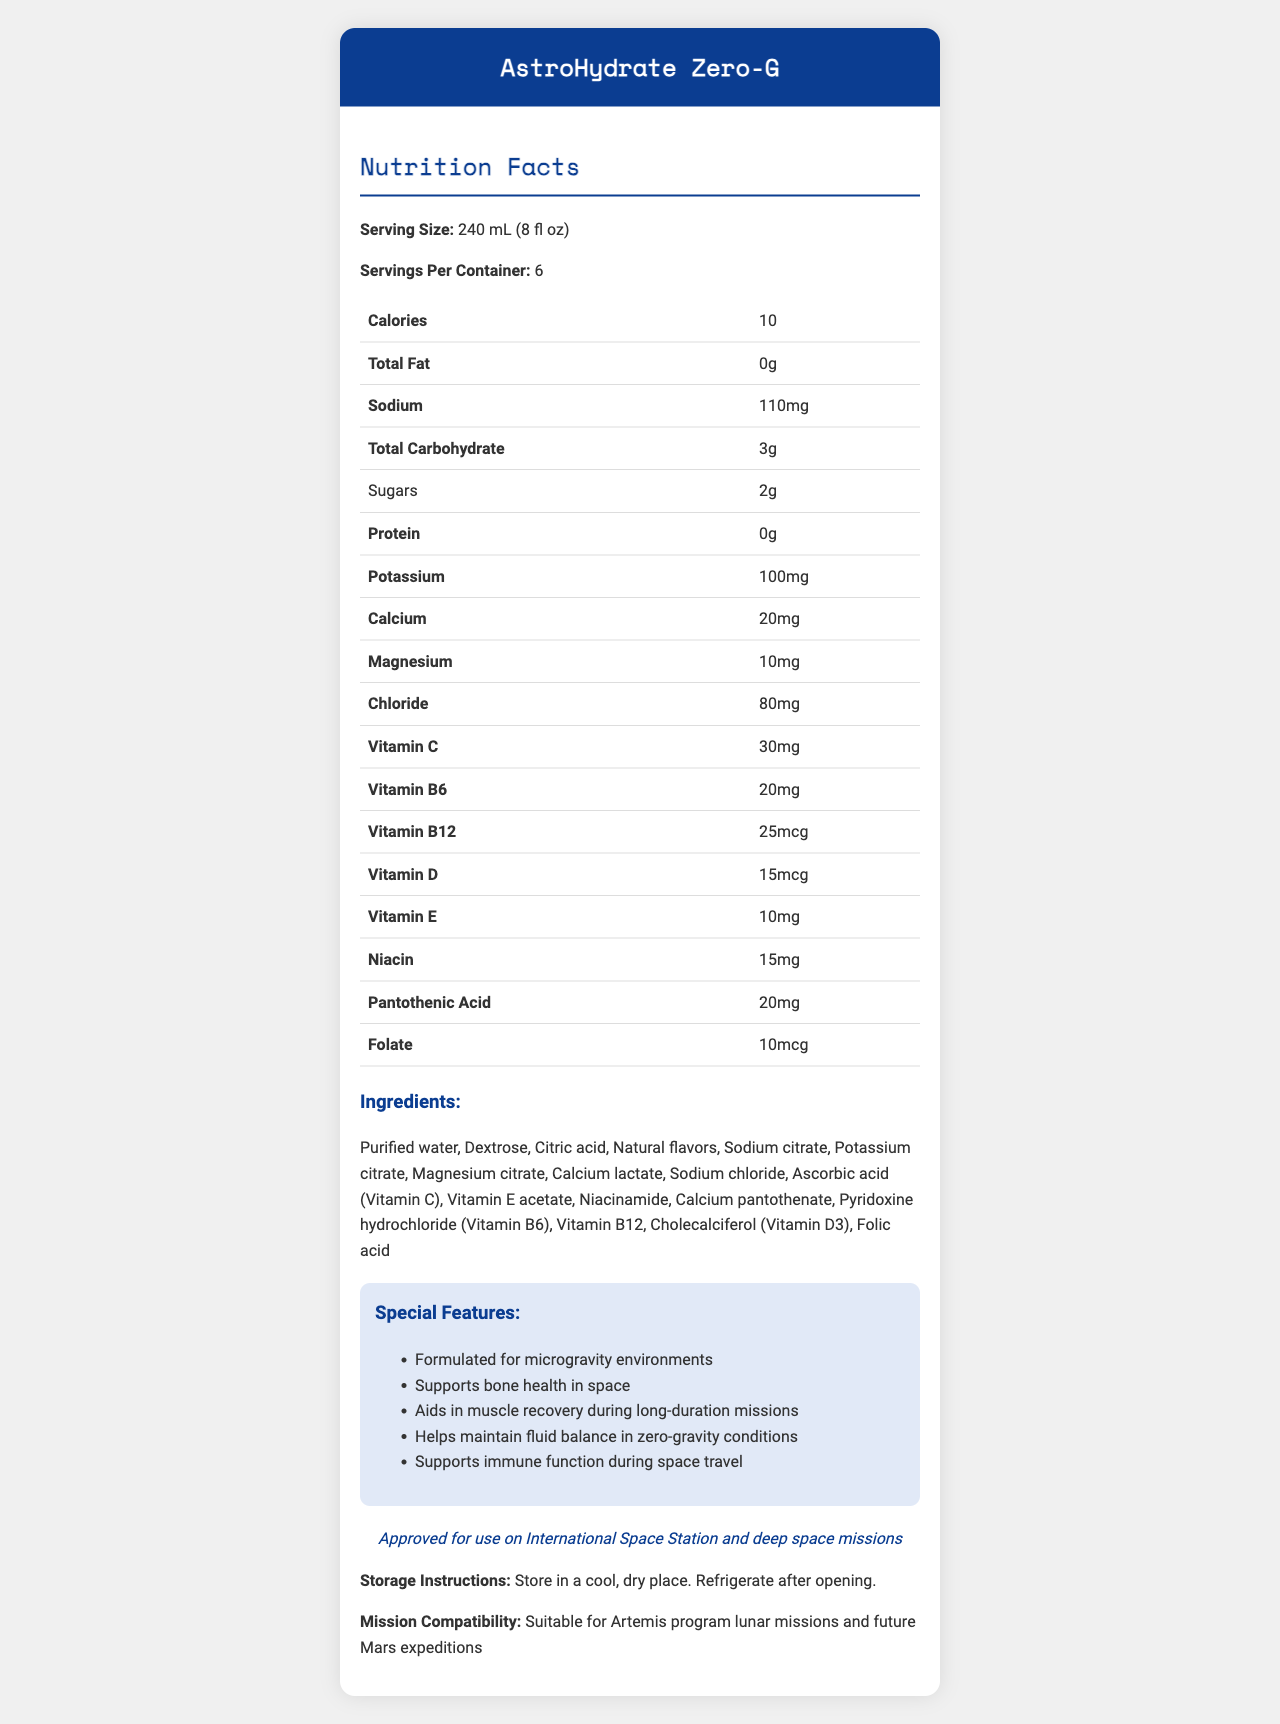what is the serving size for AstroHydrate Zero-G? The serving size is clearly stated at the beginning of the nutrition facts section.
Answer: 240 mL (8 fl oz) how many calories are there per serving of AstroHydrate Zero-G? The number of calories per serving is listed in the nutrition facts table.
Answer: 10 what vitamins are included in AstroHydrate Zero-G? The nutrition facts table lists all the vitamins included in the drink.
Answer: Vitamins C, B6, B12, D, E, Niacin, Pantothenic Acid, Folate how much sodium is in one serving of AstroHydrate Zero-G? The sodium content is listed as 110 mg in the nutrition facts table.
Answer: 110 mg which ingredient is listed first in the ingredients list? The ingredients are listed in order of quantity, with purified water being the first ingredient.
Answer: Purified water which of the following features is NOT mentioned as a special feature of AstroHydrate Zero-G? A. Supports bone health in space B. Aids in muscle recovery during long-duration missions C. Provides energy boost D. Helps maintain fluid balance in zero-gravity conditions Providing an energy boost is not mentioned as a special feature of the product.
Answer: C. Provides energy boost what is the total carbohydrate content in one serving of AstroHydrate Zero-G? A. 2g B. 3g C. 4g D. 5g The nutrition facts table lists the total carbohydrate content as 3g per serving.
Answer: B. 3g is AstroHydrate Zero-G suitable for future Mars expeditions? The document states that it is suitable for Artemis program lunar missions and future Mars expeditions.
Answer: Yes summarize the main idea of the document. The document presents a detailed description of the ingredients, nutritional content, and special features of AstroHydrate Zero-G, emphasizing its suitability for space missions.
Answer: AstroHydrate Zero-G is a hydration drink designed for astronauts, providing essential electrolytes and vitamins to support health in zero-gravity environments. It is NASA-certified for use on the International Space Station and future space missions, including those to Mars. how is AstroHydrate Zero-G stored after opening? The storage instructions specify that the drink should be refrigerated after opening.
Answer: Refrigerate after opening what is the role of calcium in AstroHydrate Zero-G? The document lists the amount of calcium but does not specify its exact role in the drink.
Answer: Not enough information what is the total number of servings per container of AstroHydrate Zero-G? The number of servings per container is clearly stated in the nutrition facts section.
Answer: 6 servings 